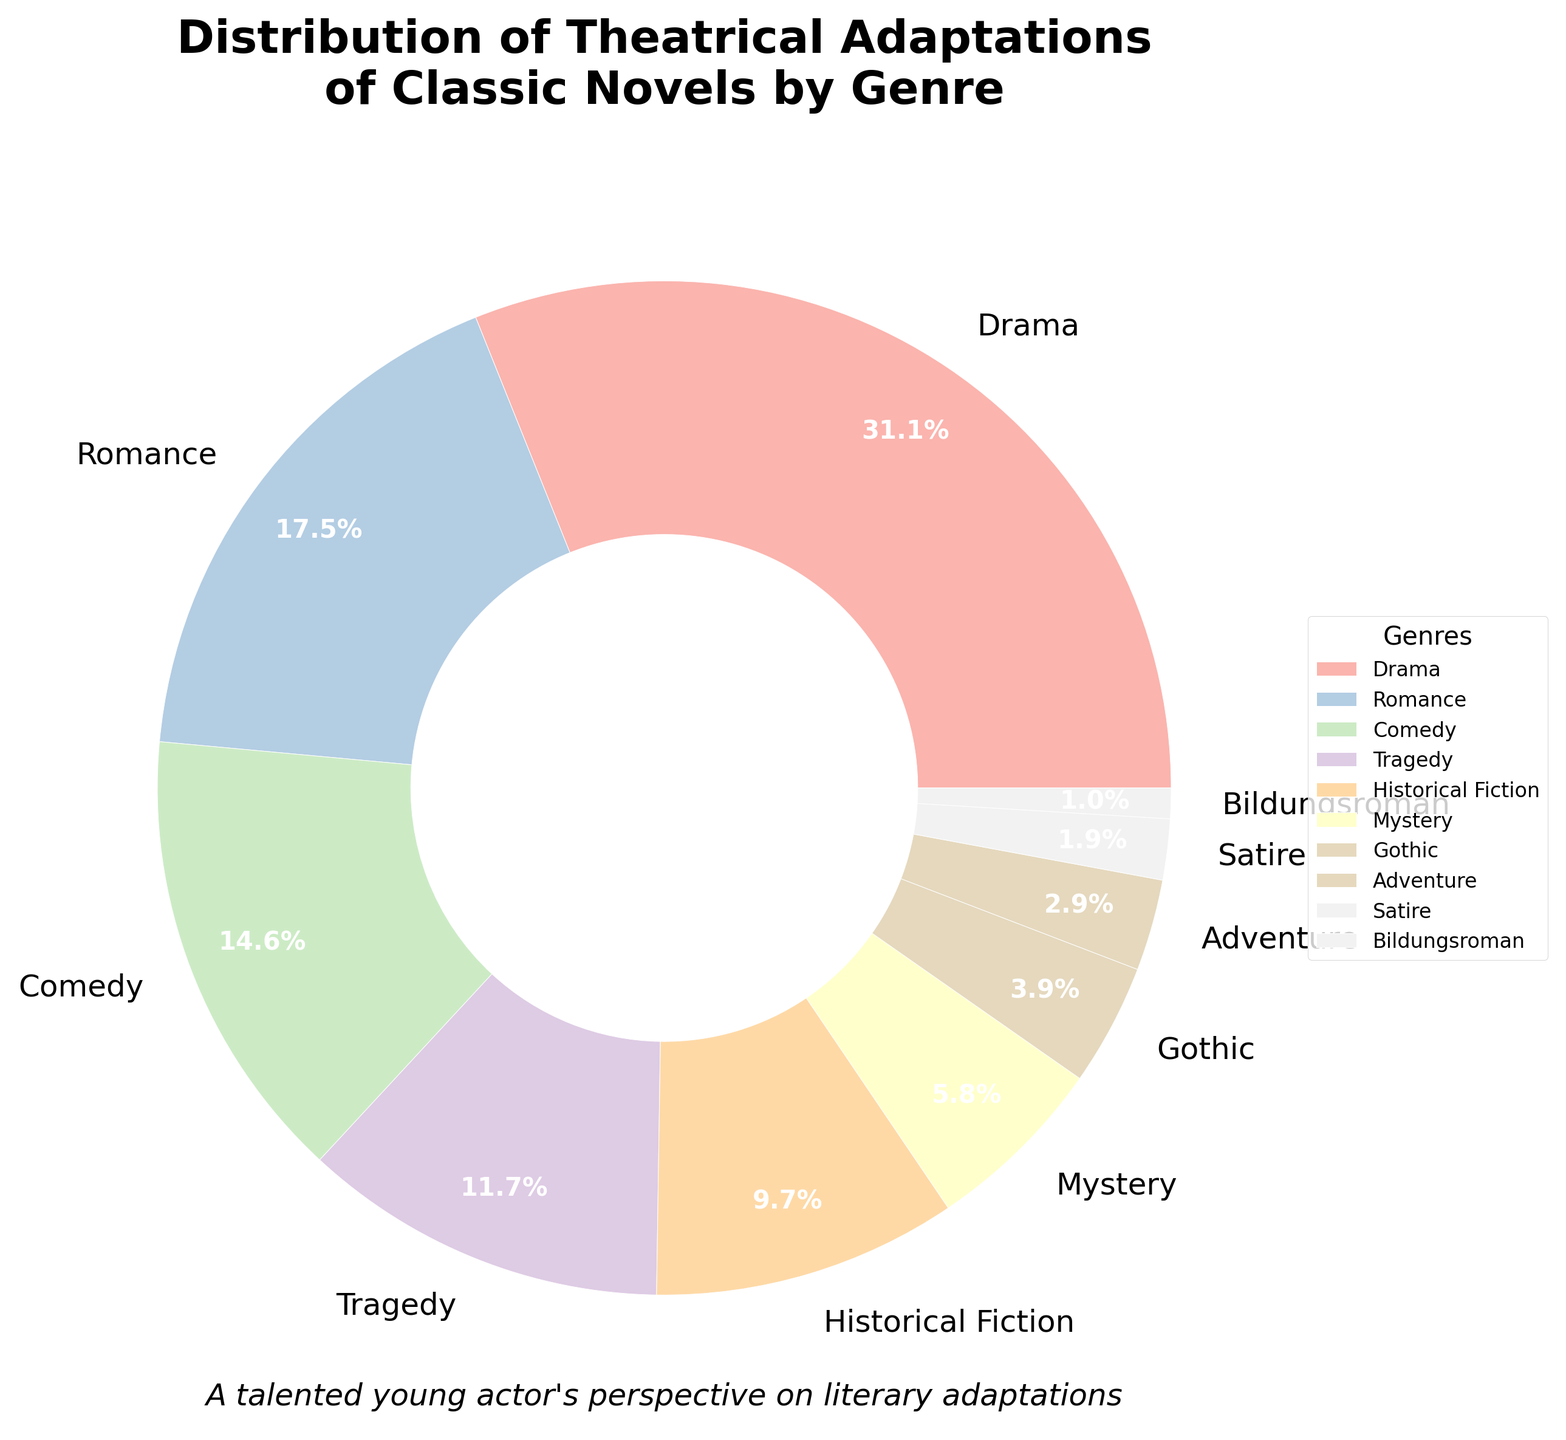What's the sum of the percentages for Drama and Romance genres? First, find the percentages for Drama (32%) and Romance (18%). Sum them up: 32 + 18 = 50
Answer: 50 Which genre has the smallest percentage? Look for the genre with the smallest slice in the pie chart. The smallest percentage is 1%, which corresponds to the Bildungsroman genre.
Answer: Bildungsroman Are there more adaptations of comedies or tragedies? Compare the percentages for Comedy (15%) and Tragedy (12%). Comedy has a higher percentage than Tragedy.
Answer: Comedy What is the difference between the percentages of Drama and Mystery genres? Find the percentage for Drama (32%) and Mystery (6%). Subtract the percentage of Mystery from Drama: 32 - 6 = 26
Answer: 26 How many genres have a percentage greater than 10%? Identify the genres with percentages over 10%: Drama (32%), Romance (18%), Comedy (15%), and Tragedy (12%). Count these genres: 4
Answer: 4 Which genre has nearly half the percentage of Drama? Calculate half of Drama's percentage: 32 / 2 = 16. Find the genre closest to 16%, which is Romance at 18%.
Answer: Romance Is the proportion of Historical Fiction adaptations greater than that of Gothic adaptations? Compare the percentages for Historical Fiction (10%) and Gothic (4%). Historical Fiction has a higher percentage.
Answer: Yes What is the total percentage of adaptations for genres less than 5%? Identify the genres with less than 5%: Gothic (4%), Adventure (3%), Satire (2%), and Bildungsroman (1%). Sum these percentages: 4 + 3 + 2 + 1 = 10
Answer: 10 Which genre adapts more frequently than Adventure but less frequently than Tragedy? Adventure has 3%, and Tragedy has 12%. The genre with a percentage between them is Mystery with 6%.
Answer: Mystery 